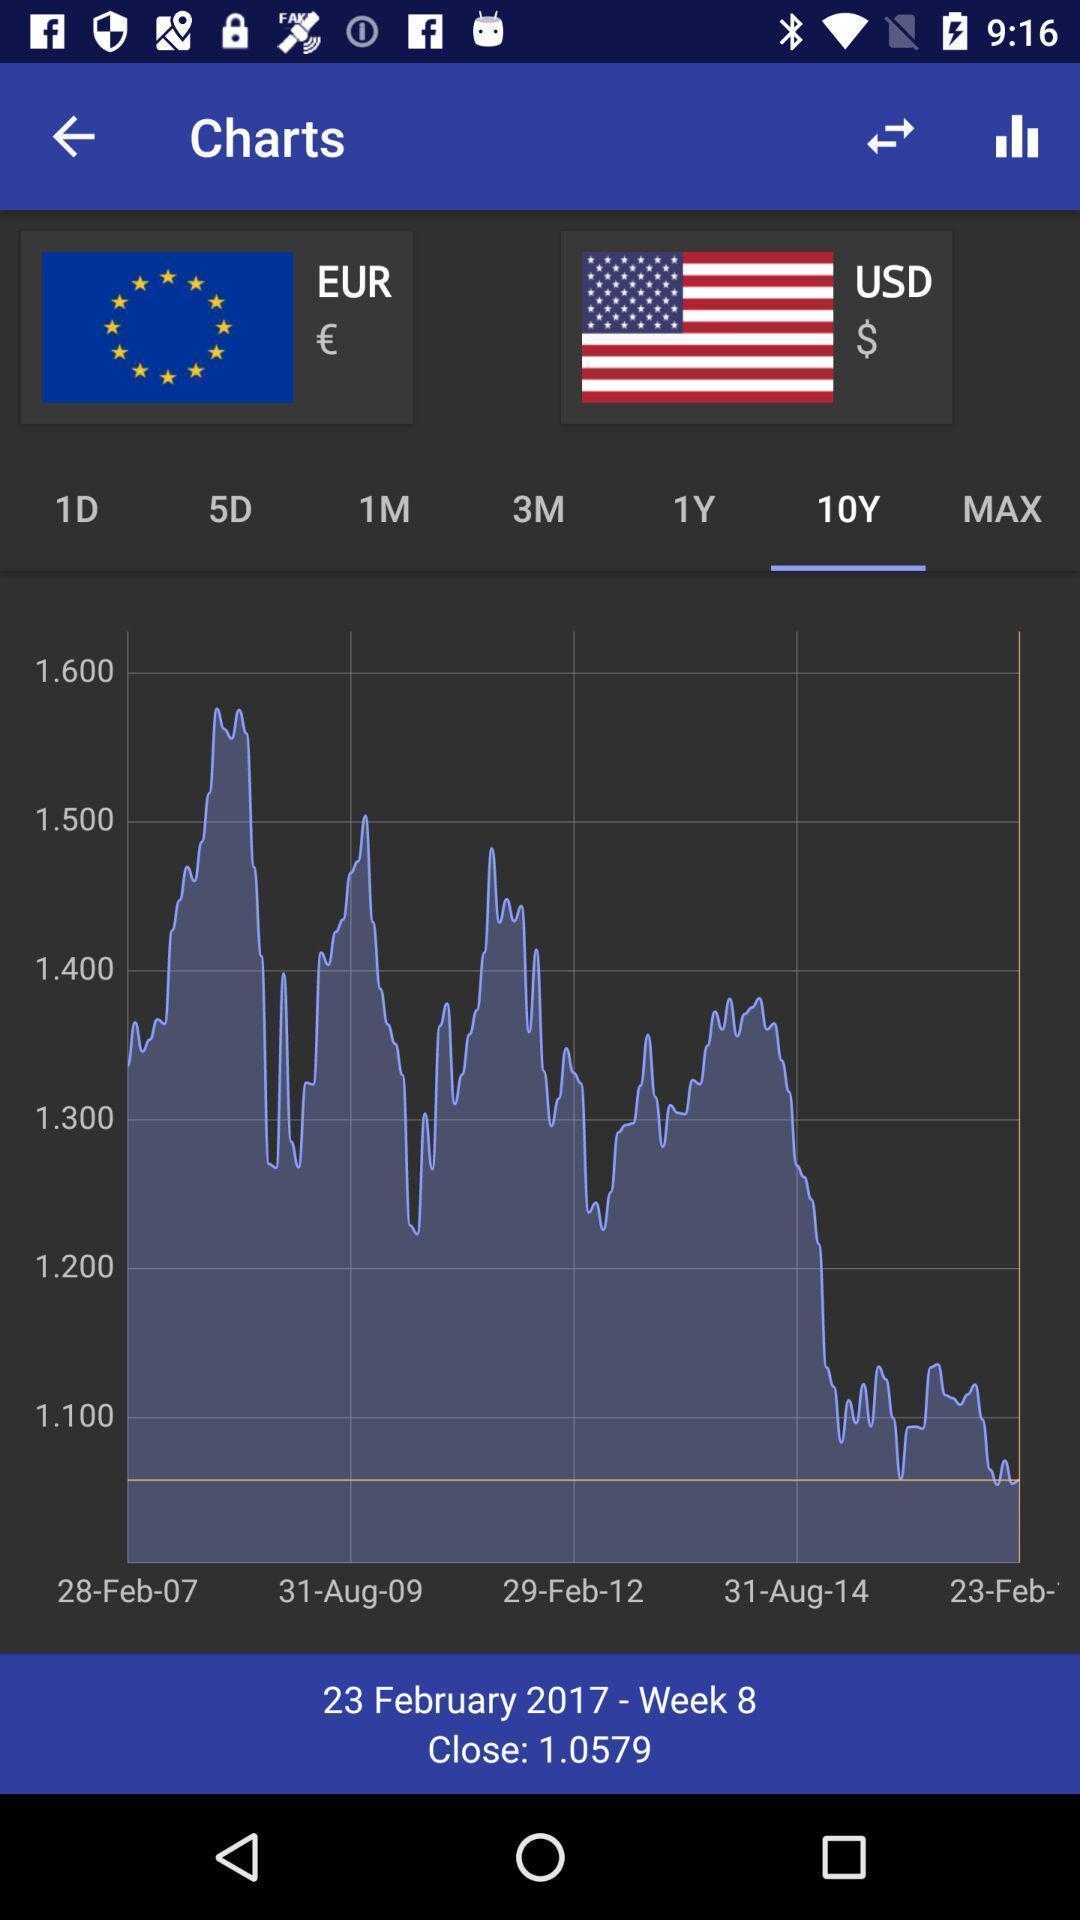Summarize the main components in this picture. Screen shows all currencies on a graph. 